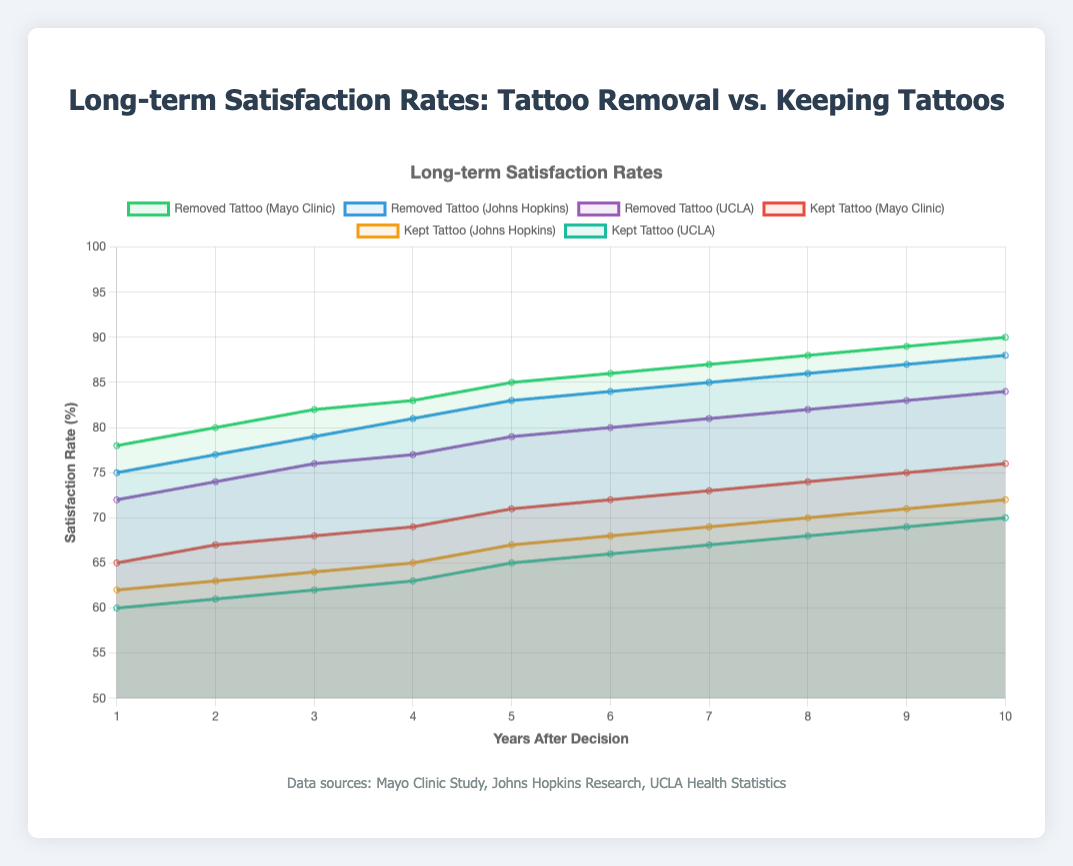What is the satisfaction rate for those who chose to remove their tattoos after 10 years according to the Mayo Clinic Study? Look for the "Removed Tattoo (Mayo Clinic)" dataset and find the satisfaction rate at year 10.
Answer: 90 How do the satisfaction rates of those who kept their tattoos compare between the Mayo Clinic Study and Johns Hopkins Research in year 5? Look at the satisfaction rates for "Kept Tattoo (Mayo Clinic)" and "Kept Tattoo (Johns Hopkins)" at year 5. Mayo Clinic is 71%, and Johns Hopkins is 67%.
Answer: Mayo Clinic: 71, Johns Hopkins: 67 What is the average satisfaction rate for those who kept their tattoos according to the UCLA Health Statistics over the 10 years? Sum the satisfaction rates for "Kept Tattoo (UCLA)" across the 10 years first: 60 + 61 + 62 + 63 + 65 + 66 + 67 + 68 + 69 + 70 = 591. Then, divide by 10.
Answer: 59.1 Which dataset shows the highest satisfaction rate in the second year of measuring for individuals who removed their tattoos? Compare the second-year satisfaction rates for "Removed Tattoo" across the three studies: Mayo Clinic (80), Johns Hopkins (77), UCLA (74).
Answer: Mayo Clinic: 80 Over the 10 years, which study shows a greater improvement in satisfaction rates for those who removed their tattoos: Mayo Clinic or Johns Hopkins? Calculate the increase in satisfaction rates from year 1 to year 10 for both studies. Mayo Clinic: 90 - 78 = 12, Johns Hopkins: 88 - 75 = 13.
Answer: Johns Hopkins: 13 In year 7, how do the visual attributes differ between satisfaction rates for those who kept their tattoos according to Mayo Clinic and those who removed their tattoos according to UCLA? Observe the lines for "Kept Tattoo (Mayo Clinic)" and "Removed Tattoo (UCLA)" in year 7. The Mayo Clinic kept tattoo line is red and the UCLA removed tattoo line is purple. Their corresponding rates are 73 and 81.
Answer: Mayo Clinic: red, 73; UCLA: purple, 81 Between years 6 and 8, how much does the satisfaction rate increase for those who kept their tattoos according to the Johns Hopkins study? First, note the satisfaction rates at years 6 and 8: 68 and 70 respectively. Then, subtract the value at year 6 from the value at year 8.
Answer: 2 What is the difference in satisfaction rates between the Mayo Clinic and UCLA statistics for those who removed their tattoos after 4 years? Locate the 4th-year satisfaction rates for "Removed Tattoo (Mayo Clinic)" and "Removed Tattoo (UCLA)." Mayo Clinic is 83, UCLA is 77. Subtract UCLA's rate from Mayo Clinic's rate.
Answer: 6 For individuals who kept their tattoos, which study shows the least variability in satisfaction rates over the 10 years? Compare the ranges of satisfaction rates over the 10 years for "Kept Tattoo" in all three studies. Calculate as: Mayo Clinic (76-65), Johns Hopkins (72-62), UCLA (70-60). All have a range of 10, indicating they are the same.
Answer: Equal variability 